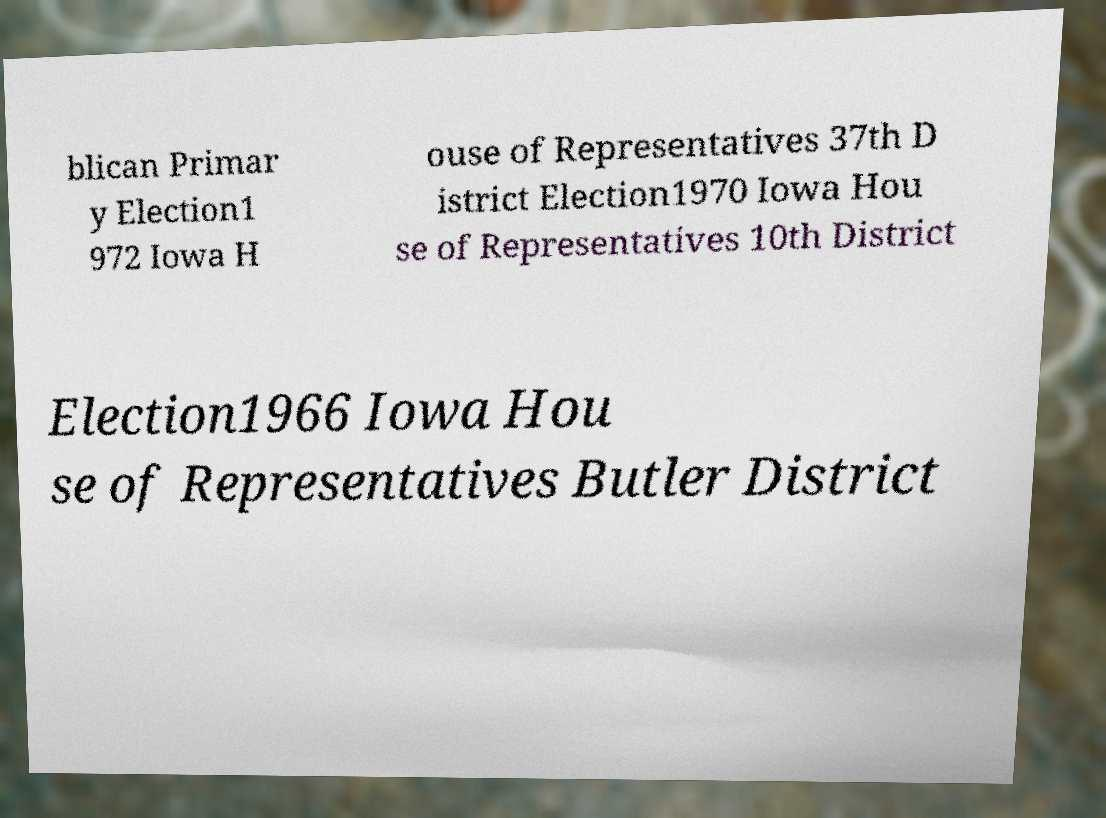Can you accurately transcribe the text from the provided image for me? blican Primar y Election1 972 Iowa H ouse of Representatives 37th D istrict Election1970 Iowa Hou se of Representatives 10th District Election1966 Iowa Hou se of Representatives Butler District 